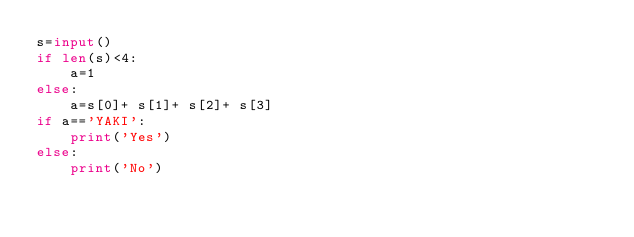<code> <loc_0><loc_0><loc_500><loc_500><_Python_>s=input()
if len(s)<4:
    a=1
else:
    a=s[0]+ s[1]+ s[2]+ s[3]
if a=='YAKI':
    print('Yes')
else:
    print('No')</code> 